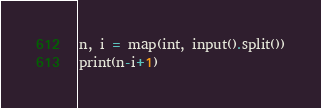<code> <loc_0><loc_0><loc_500><loc_500><_Python_>n, i = map(int, input().split())
print(n-i+1)</code> 